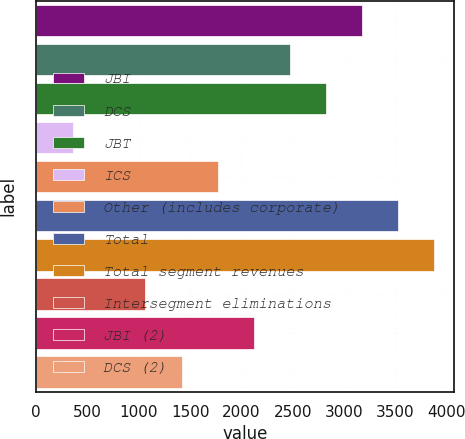<chart> <loc_0><loc_0><loc_500><loc_500><bar_chart><fcel>JBI<fcel>DCS<fcel>JBT<fcel>ICS<fcel>Other (includes corporate)<fcel>Total<fcel>Total segment revenues<fcel>Intersegment eliminations<fcel>JBI (2)<fcel>DCS (2)<nl><fcel>3172.7<fcel>2470.1<fcel>2821.4<fcel>362.3<fcel>1767.5<fcel>3524<fcel>3875.3<fcel>1064.9<fcel>2118.8<fcel>1416.2<nl></chart> 